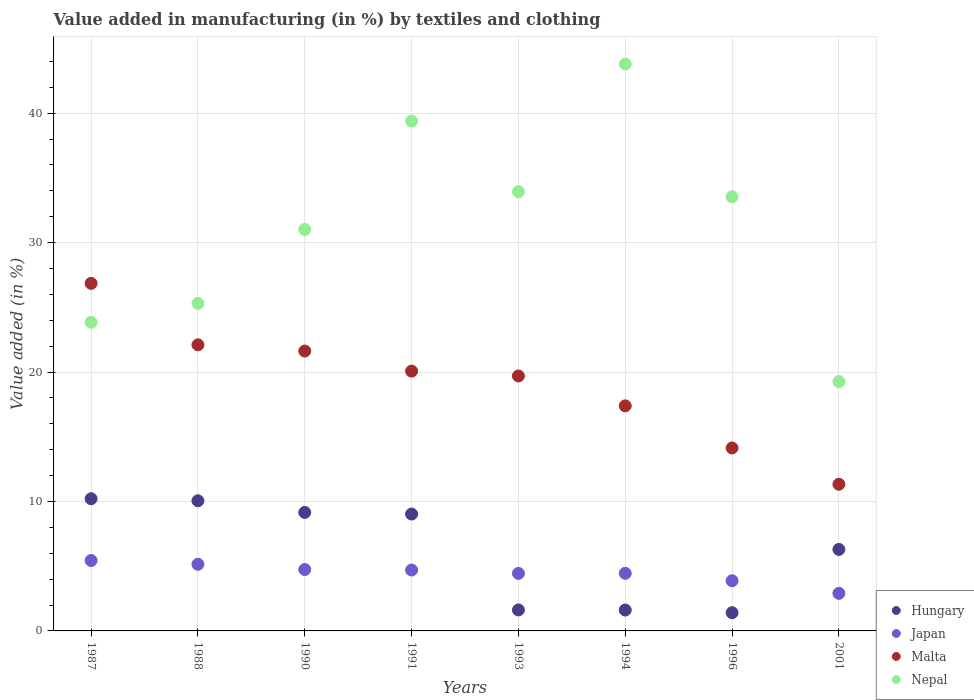Is the number of dotlines equal to the number of legend labels?
Provide a succinct answer. Yes. What is the percentage of value added in manufacturing by textiles and clothing in Malta in 2001?
Your response must be concise. 11.33. Across all years, what is the maximum percentage of value added in manufacturing by textiles and clothing in Hungary?
Keep it short and to the point. 10.21. Across all years, what is the minimum percentage of value added in manufacturing by textiles and clothing in Hungary?
Your answer should be very brief. 1.41. In which year was the percentage of value added in manufacturing by textiles and clothing in Nepal minimum?
Your response must be concise. 2001. What is the total percentage of value added in manufacturing by textiles and clothing in Japan in the graph?
Provide a succinct answer. 35.71. What is the difference between the percentage of value added in manufacturing by textiles and clothing in Malta in 1988 and that in 1996?
Ensure brevity in your answer.  7.97. What is the difference between the percentage of value added in manufacturing by textiles and clothing in Nepal in 1993 and the percentage of value added in manufacturing by textiles and clothing in Hungary in 1991?
Your answer should be very brief. 24.9. What is the average percentage of value added in manufacturing by textiles and clothing in Hungary per year?
Your answer should be very brief. 6.17. In the year 1990, what is the difference between the percentage of value added in manufacturing by textiles and clothing in Nepal and percentage of value added in manufacturing by textiles and clothing in Japan?
Your answer should be compact. 26.27. In how many years, is the percentage of value added in manufacturing by textiles and clothing in Hungary greater than 38 %?
Offer a terse response. 0. What is the ratio of the percentage of value added in manufacturing by textiles and clothing in Nepal in 1987 to that in 1991?
Provide a short and direct response. 0.61. Is the difference between the percentage of value added in manufacturing by textiles and clothing in Nepal in 1991 and 1993 greater than the difference between the percentage of value added in manufacturing by textiles and clothing in Japan in 1991 and 1993?
Provide a succinct answer. Yes. What is the difference between the highest and the second highest percentage of value added in manufacturing by textiles and clothing in Hungary?
Keep it short and to the point. 0.16. What is the difference between the highest and the lowest percentage of value added in manufacturing by textiles and clothing in Japan?
Offer a very short reply. 2.54. Is it the case that in every year, the sum of the percentage of value added in manufacturing by textiles and clothing in Nepal and percentage of value added in manufacturing by textiles and clothing in Malta  is greater than the sum of percentage of value added in manufacturing by textiles and clothing in Hungary and percentage of value added in manufacturing by textiles and clothing in Japan?
Give a very brief answer. Yes. How many years are there in the graph?
Offer a terse response. 8. What is the difference between two consecutive major ticks on the Y-axis?
Offer a terse response. 10. Are the values on the major ticks of Y-axis written in scientific E-notation?
Make the answer very short. No. Where does the legend appear in the graph?
Provide a succinct answer. Bottom right. How are the legend labels stacked?
Your answer should be very brief. Vertical. What is the title of the graph?
Give a very brief answer. Value added in manufacturing (in %) by textiles and clothing. Does "Trinidad and Tobago" appear as one of the legend labels in the graph?
Provide a succinct answer. No. What is the label or title of the X-axis?
Provide a short and direct response. Years. What is the label or title of the Y-axis?
Make the answer very short. Value added (in %). What is the Value added (in %) of Hungary in 1987?
Your answer should be very brief. 10.21. What is the Value added (in %) of Japan in 1987?
Your answer should be compact. 5.44. What is the Value added (in %) of Malta in 1987?
Ensure brevity in your answer.  26.85. What is the Value added (in %) in Nepal in 1987?
Provide a short and direct response. 23.84. What is the Value added (in %) of Hungary in 1988?
Keep it short and to the point. 10.05. What is the Value added (in %) of Japan in 1988?
Offer a terse response. 5.15. What is the Value added (in %) of Malta in 1988?
Provide a short and direct response. 22.1. What is the Value added (in %) of Nepal in 1988?
Keep it short and to the point. 25.3. What is the Value added (in %) in Hungary in 1990?
Your response must be concise. 9.15. What is the Value added (in %) in Japan in 1990?
Ensure brevity in your answer.  4.74. What is the Value added (in %) in Malta in 1990?
Your answer should be very brief. 21.62. What is the Value added (in %) in Nepal in 1990?
Give a very brief answer. 31.02. What is the Value added (in %) of Hungary in 1991?
Your answer should be compact. 9.03. What is the Value added (in %) in Japan in 1991?
Ensure brevity in your answer.  4.7. What is the Value added (in %) of Malta in 1991?
Offer a very short reply. 20.07. What is the Value added (in %) of Nepal in 1991?
Your answer should be compact. 39.39. What is the Value added (in %) of Hungary in 1993?
Your response must be concise. 1.62. What is the Value added (in %) of Japan in 1993?
Give a very brief answer. 4.45. What is the Value added (in %) of Malta in 1993?
Your answer should be very brief. 19.69. What is the Value added (in %) in Nepal in 1993?
Provide a succinct answer. 33.93. What is the Value added (in %) in Hungary in 1994?
Keep it short and to the point. 1.61. What is the Value added (in %) of Japan in 1994?
Keep it short and to the point. 4.45. What is the Value added (in %) in Malta in 1994?
Give a very brief answer. 17.39. What is the Value added (in %) of Nepal in 1994?
Keep it short and to the point. 43.79. What is the Value added (in %) in Hungary in 1996?
Give a very brief answer. 1.41. What is the Value added (in %) in Japan in 1996?
Keep it short and to the point. 3.87. What is the Value added (in %) in Malta in 1996?
Keep it short and to the point. 14.13. What is the Value added (in %) in Nepal in 1996?
Provide a succinct answer. 33.54. What is the Value added (in %) in Hungary in 2001?
Give a very brief answer. 6.3. What is the Value added (in %) in Japan in 2001?
Offer a very short reply. 2.9. What is the Value added (in %) of Malta in 2001?
Offer a very short reply. 11.33. What is the Value added (in %) in Nepal in 2001?
Offer a terse response. 19.26. Across all years, what is the maximum Value added (in %) in Hungary?
Offer a terse response. 10.21. Across all years, what is the maximum Value added (in %) of Japan?
Your response must be concise. 5.44. Across all years, what is the maximum Value added (in %) of Malta?
Your response must be concise. 26.85. Across all years, what is the maximum Value added (in %) in Nepal?
Your answer should be compact. 43.79. Across all years, what is the minimum Value added (in %) in Hungary?
Keep it short and to the point. 1.41. Across all years, what is the minimum Value added (in %) of Japan?
Provide a succinct answer. 2.9. Across all years, what is the minimum Value added (in %) of Malta?
Give a very brief answer. 11.33. Across all years, what is the minimum Value added (in %) of Nepal?
Give a very brief answer. 19.26. What is the total Value added (in %) of Hungary in the graph?
Your answer should be compact. 49.38. What is the total Value added (in %) in Japan in the graph?
Offer a very short reply. 35.71. What is the total Value added (in %) in Malta in the graph?
Keep it short and to the point. 153.18. What is the total Value added (in %) of Nepal in the graph?
Ensure brevity in your answer.  250.07. What is the difference between the Value added (in %) of Hungary in 1987 and that in 1988?
Provide a succinct answer. 0.16. What is the difference between the Value added (in %) in Japan in 1987 and that in 1988?
Provide a succinct answer. 0.29. What is the difference between the Value added (in %) in Malta in 1987 and that in 1988?
Make the answer very short. 4.75. What is the difference between the Value added (in %) of Nepal in 1987 and that in 1988?
Give a very brief answer. -1.45. What is the difference between the Value added (in %) of Hungary in 1987 and that in 1990?
Your response must be concise. 1.06. What is the difference between the Value added (in %) of Japan in 1987 and that in 1990?
Make the answer very short. 0.7. What is the difference between the Value added (in %) in Malta in 1987 and that in 1990?
Provide a short and direct response. 5.23. What is the difference between the Value added (in %) of Nepal in 1987 and that in 1990?
Keep it short and to the point. -7.17. What is the difference between the Value added (in %) of Hungary in 1987 and that in 1991?
Your response must be concise. 1.18. What is the difference between the Value added (in %) in Japan in 1987 and that in 1991?
Give a very brief answer. 0.74. What is the difference between the Value added (in %) in Malta in 1987 and that in 1991?
Provide a short and direct response. 6.78. What is the difference between the Value added (in %) of Nepal in 1987 and that in 1991?
Offer a terse response. -15.54. What is the difference between the Value added (in %) in Hungary in 1987 and that in 1993?
Provide a succinct answer. 8.59. What is the difference between the Value added (in %) of Japan in 1987 and that in 1993?
Your answer should be compact. 1. What is the difference between the Value added (in %) in Malta in 1987 and that in 1993?
Offer a very short reply. 7.15. What is the difference between the Value added (in %) in Nepal in 1987 and that in 1993?
Ensure brevity in your answer.  -10.09. What is the difference between the Value added (in %) in Hungary in 1987 and that in 1994?
Give a very brief answer. 8.6. What is the difference between the Value added (in %) of Malta in 1987 and that in 1994?
Ensure brevity in your answer.  9.46. What is the difference between the Value added (in %) in Nepal in 1987 and that in 1994?
Your answer should be very brief. -19.95. What is the difference between the Value added (in %) of Hungary in 1987 and that in 1996?
Your answer should be very brief. 8.8. What is the difference between the Value added (in %) in Japan in 1987 and that in 1996?
Your response must be concise. 1.57. What is the difference between the Value added (in %) of Malta in 1987 and that in 1996?
Make the answer very short. 12.71. What is the difference between the Value added (in %) of Nepal in 1987 and that in 1996?
Provide a succinct answer. -9.7. What is the difference between the Value added (in %) in Hungary in 1987 and that in 2001?
Your answer should be very brief. 3.92. What is the difference between the Value added (in %) of Japan in 1987 and that in 2001?
Provide a succinct answer. 2.54. What is the difference between the Value added (in %) of Malta in 1987 and that in 2001?
Give a very brief answer. 15.52. What is the difference between the Value added (in %) of Nepal in 1987 and that in 2001?
Give a very brief answer. 4.58. What is the difference between the Value added (in %) of Hungary in 1988 and that in 1990?
Your response must be concise. 0.9. What is the difference between the Value added (in %) of Japan in 1988 and that in 1990?
Offer a terse response. 0.4. What is the difference between the Value added (in %) in Malta in 1988 and that in 1990?
Offer a terse response. 0.48. What is the difference between the Value added (in %) of Nepal in 1988 and that in 1990?
Offer a very short reply. -5.72. What is the difference between the Value added (in %) in Hungary in 1988 and that in 1991?
Make the answer very short. 1.03. What is the difference between the Value added (in %) of Japan in 1988 and that in 1991?
Offer a very short reply. 0.44. What is the difference between the Value added (in %) of Malta in 1988 and that in 1991?
Provide a succinct answer. 2.03. What is the difference between the Value added (in %) of Nepal in 1988 and that in 1991?
Your answer should be very brief. -14.09. What is the difference between the Value added (in %) of Hungary in 1988 and that in 1993?
Make the answer very short. 8.43. What is the difference between the Value added (in %) in Japan in 1988 and that in 1993?
Give a very brief answer. 0.7. What is the difference between the Value added (in %) in Malta in 1988 and that in 1993?
Your answer should be compact. 2.41. What is the difference between the Value added (in %) in Nepal in 1988 and that in 1993?
Provide a succinct answer. -8.63. What is the difference between the Value added (in %) of Hungary in 1988 and that in 1994?
Provide a succinct answer. 8.44. What is the difference between the Value added (in %) of Japan in 1988 and that in 1994?
Offer a very short reply. 0.7. What is the difference between the Value added (in %) of Malta in 1988 and that in 1994?
Your answer should be compact. 4.71. What is the difference between the Value added (in %) of Nepal in 1988 and that in 1994?
Offer a very short reply. -18.5. What is the difference between the Value added (in %) of Hungary in 1988 and that in 1996?
Keep it short and to the point. 8.65. What is the difference between the Value added (in %) in Japan in 1988 and that in 1996?
Your answer should be very brief. 1.27. What is the difference between the Value added (in %) of Malta in 1988 and that in 1996?
Your answer should be very brief. 7.97. What is the difference between the Value added (in %) of Nepal in 1988 and that in 1996?
Provide a succinct answer. -8.24. What is the difference between the Value added (in %) of Hungary in 1988 and that in 2001?
Your answer should be compact. 3.76. What is the difference between the Value added (in %) of Japan in 1988 and that in 2001?
Provide a succinct answer. 2.25. What is the difference between the Value added (in %) in Malta in 1988 and that in 2001?
Provide a succinct answer. 10.77. What is the difference between the Value added (in %) of Nepal in 1988 and that in 2001?
Offer a very short reply. 6.03. What is the difference between the Value added (in %) of Hungary in 1990 and that in 1991?
Offer a very short reply. 0.13. What is the difference between the Value added (in %) of Japan in 1990 and that in 1991?
Your answer should be compact. 0.04. What is the difference between the Value added (in %) of Malta in 1990 and that in 1991?
Provide a succinct answer. 1.55. What is the difference between the Value added (in %) in Nepal in 1990 and that in 1991?
Provide a short and direct response. -8.37. What is the difference between the Value added (in %) in Hungary in 1990 and that in 1993?
Your response must be concise. 7.53. What is the difference between the Value added (in %) in Japan in 1990 and that in 1993?
Your answer should be compact. 0.3. What is the difference between the Value added (in %) of Malta in 1990 and that in 1993?
Ensure brevity in your answer.  1.93. What is the difference between the Value added (in %) in Nepal in 1990 and that in 1993?
Offer a terse response. -2.91. What is the difference between the Value added (in %) in Hungary in 1990 and that in 1994?
Offer a very short reply. 7.54. What is the difference between the Value added (in %) in Japan in 1990 and that in 1994?
Ensure brevity in your answer.  0.29. What is the difference between the Value added (in %) of Malta in 1990 and that in 1994?
Make the answer very short. 4.23. What is the difference between the Value added (in %) of Nepal in 1990 and that in 1994?
Your answer should be very brief. -12.78. What is the difference between the Value added (in %) in Hungary in 1990 and that in 1996?
Make the answer very short. 7.75. What is the difference between the Value added (in %) in Japan in 1990 and that in 1996?
Make the answer very short. 0.87. What is the difference between the Value added (in %) in Malta in 1990 and that in 1996?
Make the answer very short. 7.49. What is the difference between the Value added (in %) in Nepal in 1990 and that in 1996?
Make the answer very short. -2.52. What is the difference between the Value added (in %) in Hungary in 1990 and that in 2001?
Give a very brief answer. 2.86. What is the difference between the Value added (in %) of Japan in 1990 and that in 2001?
Your answer should be compact. 1.84. What is the difference between the Value added (in %) of Malta in 1990 and that in 2001?
Offer a terse response. 10.29. What is the difference between the Value added (in %) of Nepal in 1990 and that in 2001?
Make the answer very short. 11.75. What is the difference between the Value added (in %) of Hungary in 1991 and that in 1993?
Keep it short and to the point. 7.41. What is the difference between the Value added (in %) in Japan in 1991 and that in 1993?
Your answer should be compact. 0.26. What is the difference between the Value added (in %) of Malta in 1991 and that in 1993?
Your answer should be compact. 0.38. What is the difference between the Value added (in %) in Nepal in 1991 and that in 1993?
Ensure brevity in your answer.  5.46. What is the difference between the Value added (in %) of Hungary in 1991 and that in 1994?
Provide a short and direct response. 7.42. What is the difference between the Value added (in %) in Japan in 1991 and that in 1994?
Provide a succinct answer. 0.25. What is the difference between the Value added (in %) of Malta in 1991 and that in 1994?
Ensure brevity in your answer.  2.68. What is the difference between the Value added (in %) in Nepal in 1991 and that in 1994?
Offer a very short reply. -4.41. What is the difference between the Value added (in %) of Hungary in 1991 and that in 1996?
Provide a succinct answer. 7.62. What is the difference between the Value added (in %) of Japan in 1991 and that in 1996?
Offer a very short reply. 0.83. What is the difference between the Value added (in %) of Malta in 1991 and that in 1996?
Provide a short and direct response. 5.94. What is the difference between the Value added (in %) in Nepal in 1991 and that in 1996?
Ensure brevity in your answer.  5.85. What is the difference between the Value added (in %) of Hungary in 1991 and that in 2001?
Offer a very short reply. 2.73. What is the difference between the Value added (in %) of Japan in 1991 and that in 2001?
Offer a terse response. 1.8. What is the difference between the Value added (in %) of Malta in 1991 and that in 2001?
Keep it short and to the point. 8.74. What is the difference between the Value added (in %) in Nepal in 1991 and that in 2001?
Make the answer very short. 20.12. What is the difference between the Value added (in %) of Hungary in 1993 and that in 1994?
Your response must be concise. 0.01. What is the difference between the Value added (in %) of Japan in 1993 and that in 1994?
Offer a terse response. -0.01. What is the difference between the Value added (in %) in Malta in 1993 and that in 1994?
Offer a very short reply. 2.31. What is the difference between the Value added (in %) in Nepal in 1993 and that in 1994?
Offer a terse response. -9.86. What is the difference between the Value added (in %) of Hungary in 1993 and that in 1996?
Your answer should be compact. 0.21. What is the difference between the Value added (in %) in Japan in 1993 and that in 1996?
Offer a very short reply. 0.57. What is the difference between the Value added (in %) in Malta in 1993 and that in 1996?
Keep it short and to the point. 5.56. What is the difference between the Value added (in %) in Nepal in 1993 and that in 1996?
Keep it short and to the point. 0.39. What is the difference between the Value added (in %) of Hungary in 1993 and that in 2001?
Your answer should be very brief. -4.67. What is the difference between the Value added (in %) in Japan in 1993 and that in 2001?
Give a very brief answer. 1.54. What is the difference between the Value added (in %) in Malta in 1993 and that in 2001?
Offer a terse response. 8.36. What is the difference between the Value added (in %) of Nepal in 1993 and that in 2001?
Your response must be concise. 14.67. What is the difference between the Value added (in %) of Hungary in 1994 and that in 1996?
Offer a terse response. 0.2. What is the difference between the Value added (in %) of Japan in 1994 and that in 1996?
Provide a short and direct response. 0.58. What is the difference between the Value added (in %) in Malta in 1994 and that in 1996?
Offer a very short reply. 3.25. What is the difference between the Value added (in %) of Nepal in 1994 and that in 1996?
Your answer should be compact. 10.25. What is the difference between the Value added (in %) of Hungary in 1994 and that in 2001?
Offer a terse response. -4.68. What is the difference between the Value added (in %) of Japan in 1994 and that in 2001?
Keep it short and to the point. 1.55. What is the difference between the Value added (in %) of Malta in 1994 and that in 2001?
Your answer should be compact. 6.06. What is the difference between the Value added (in %) in Nepal in 1994 and that in 2001?
Offer a very short reply. 24.53. What is the difference between the Value added (in %) of Hungary in 1996 and that in 2001?
Keep it short and to the point. -4.89. What is the difference between the Value added (in %) in Japan in 1996 and that in 2001?
Offer a terse response. 0.97. What is the difference between the Value added (in %) in Malta in 1996 and that in 2001?
Keep it short and to the point. 2.8. What is the difference between the Value added (in %) of Nepal in 1996 and that in 2001?
Your answer should be compact. 14.28. What is the difference between the Value added (in %) in Hungary in 1987 and the Value added (in %) in Japan in 1988?
Provide a short and direct response. 5.07. What is the difference between the Value added (in %) in Hungary in 1987 and the Value added (in %) in Malta in 1988?
Keep it short and to the point. -11.89. What is the difference between the Value added (in %) of Hungary in 1987 and the Value added (in %) of Nepal in 1988?
Ensure brevity in your answer.  -15.09. What is the difference between the Value added (in %) of Japan in 1987 and the Value added (in %) of Malta in 1988?
Provide a short and direct response. -16.66. What is the difference between the Value added (in %) of Japan in 1987 and the Value added (in %) of Nepal in 1988?
Keep it short and to the point. -19.86. What is the difference between the Value added (in %) of Malta in 1987 and the Value added (in %) of Nepal in 1988?
Offer a very short reply. 1.55. What is the difference between the Value added (in %) in Hungary in 1987 and the Value added (in %) in Japan in 1990?
Your answer should be compact. 5.47. What is the difference between the Value added (in %) in Hungary in 1987 and the Value added (in %) in Malta in 1990?
Ensure brevity in your answer.  -11.41. What is the difference between the Value added (in %) in Hungary in 1987 and the Value added (in %) in Nepal in 1990?
Make the answer very short. -20.8. What is the difference between the Value added (in %) in Japan in 1987 and the Value added (in %) in Malta in 1990?
Your answer should be very brief. -16.18. What is the difference between the Value added (in %) in Japan in 1987 and the Value added (in %) in Nepal in 1990?
Provide a short and direct response. -25.58. What is the difference between the Value added (in %) of Malta in 1987 and the Value added (in %) of Nepal in 1990?
Your answer should be very brief. -4.17. What is the difference between the Value added (in %) of Hungary in 1987 and the Value added (in %) of Japan in 1991?
Your answer should be compact. 5.51. What is the difference between the Value added (in %) of Hungary in 1987 and the Value added (in %) of Malta in 1991?
Keep it short and to the point. -9.86. What is the difference between the Value added (in %) of Hungary in 1987 and the Value added (in %) of Nepal in 1991?
Ensure brevity in your answer.  -29.17. What is the difference between the Value added (in %) in Japan in 1987 and the Value added (in %) in Malta in 1991?
Your response must be concise. -14.63. What is the difference between the Value added (in %) in Japan in 1987 and the Value added (in %) in Nepal in 1991?
Keep it short and to the point. -33.95. What is the difference between the Value added (in %) of Malta in 1987 and the Value added (in %) of Nepal in 1991?
Your response must be concise. -12.54. What is the difference between the Value added (in %) in Hungary in 1987 and the Value added (in %) in Japan in 1993?
Offer a terse response. 5.77. What is the difference between the Value added (in %) in Hungary in 1987 and the Value added (in %) in Malta in 1993?
Make the answer very short. -9.48. What is the difference between the Value added (in %) of Hungary in 1987 and the Value added (in %) of Nepal in 1993?
Your response must be concise. -23.72. What is the difference between the Value added (in %) of Japan in 1987 and the Value added (in %) of Malta in 1993?
Keep it short and to the point. -14.25. What is the difference between the Value added (in %) of Japan in 1987 and the Value added (in %) of Nepal in 1993?
Offer a terse response. -28.49. What is the difference between the Value added (in %) of Malta in 1987 and the Value added (in %) of Nepal in 1993?
Keep it short and to the point. -7.08. What is the difference between the Value added (in %) of Hungary in 1987 and the Value added (in %) of Japan in 1994?
Provide a short and direct response. 5.76. What is the difference between the Value added (in %) in Hungary in 1987 and the Value added (in %) in Malta in 1994?
Offer a terse response. -7.17. What is the difference between the Value added (in %) in Hungary in 1987 and the Value added (in %) in Nepal in 1994?
Provide a short and direct response. -33.58. What is the difference between the Value added (in %) in Japan in 1987 and the Value added (in %) in Malta in 1994?
Keep it short and to the point. -11.95. What is the difference between the Value added (in %) in Japan in 1987 and the Value added (in %) in Nepal in 1994?
Your response must be concise. -38.35. What is the difference between the Value added (in %) in Malta in 1987 and the Value added (in %) in Nepal in 1994?
Offer a very short reply. -16.95. What is the difference between the Value added (in %) in Hungary in 1987 and the Value added (in %) in Japan in 1996?
Your response must be concise. 6.34. What is the difference between the Value added (in %) of Hungary in 1987 and the Value added (in %) of Malta in 1996?
Offer a very short reply. -3.92. What is the difference between the Value added (in %) of Hungary in 1987 and the Value added (in %) of Nepal in 1996?
Provide a short and direct response. -23.33. What is the difference between the Value added (in %) of Japan in 1987 and the Value added (in %) of Malta in 1996?
Offer a terse response. -8.69. What is the difference between the Value added (in %) in Japan in 1987 and the Value added (in %) in Nepal in 1996?
Provide a short and direct response. -28.1. What is the difference between the Value added (in %) of Malta in 1987 and the Value added (in %) of Nepal in 1996?
Your answer should be very brief. -6.69. What is the difference between the Value added (in %) in Hungary in 1987 and the Value added (in %) in Japan in 2001?
Your answer should be compact. 7.31. What is the difference between the Value added (in %) in Hungary in 1987 and the Value added (in %) in Malta in 2001?
Give a very brief answer. -1.12. What is the difference between the Value added (in %) in Hungary in 1987 and the Value added (in %) in Nepal in 2001?
Ensure brevity in your answer.  -9.05. What is the difference between the Value added (in %) in Japan in 1987 and the Value added (in %) in Malta in 2001?
Offer a terse response. -5.89. What is the difference between the Value added (in %) in Japan in 1987 and the Value added (in %) in Nepal in 2001?
Keep it short and to the point. -13.82. What is the difference between the Value added (in %) of Malta in 1987 and the Value added (in %) of Nepal in 2001?
Your response must be concise. 7.58. What is the difference between the Value added (in %) in Hungary in 1988 and the Value added (in %) in Japan in 1990?
Provide a succinct answer. 5.31. What is the difference between the Value added (in %) of Hungary in 1988 and the Value added (in %) of Malta in 1990?
Your answer should be very brief. -11.56. What is the difference between the Value added (in %) in Hungary in 1988 and the Value added (in %) in Nepal in 1990?
Provide a short and direct response. -20.96. What is the difference between the Value added (in %) in Japan in 1988 and the Value added (in %) in Malta in 1990?
Offer a terse response. -16.47. What is the difference between the Value added (in %) in Japan in 1988 and the Value added (in %) in Nepal in 1990?
Your response must be concise. -25.87. What is the difference between the Value added (in %) in Malta in 1988 and the Value added (in %) in Nepal in 1990?
Offer a very short reply. -8.92. What is the difference between the Value added (in %) in Hungary in 1988 and the Value added (in %) in Japan in 1991?
Make the answer very short. 5.35. What is the difference between the Value added (in %) in Hungary in 1988 and the Value added (in %) in Malta in 1991?
Offer a terse response. -10.02. What is the difference between the Value added (in %) in Hungary in 1988 and the Value added (in %) in Nepal in 1991?
Make the answer very short. -29.33. What is the difference between the Value added (in %) of Japan in 1988 and the Value added (in %) of Malta in 1991?
Keep it short and to the point. -14.92. What is the difference between the Value added (in %) of Japan in 1988 and the Value added (in %) of Nepal in 1991?
Ensure brevity in your answer.  -34.24. What is the difference between the Value added (in %) of Malta in 1988 and the Value added (in %) of Nepal in 1991?
Your answer should be very brief. -17.29. What is the difference between the Value added (in %) of Hungary in 1988 and the Value added (in %) of Japan in 1993?
Your answer should be compact. 5.61. What is the difference between the Value added (in %) of Hungary in 1988 and the Value added (in %) of Malta in 1993?
Provide a succinct answer. -9.64. What is the difference between the Value added (in %) of Hungary in 1988 and the Value added (in %) of Nepal in 1993?
Make the answer very short. -23.87. What is the difference between the Value added (in %) of Japan in 1988 and the Value added (in %) of Malta in 1993?
Your answer should be compact. -14.55. What is the difference between the Value added (in %) of Japan in 1988 and the Value added (in %) of Nepal in 1993?
Your answer should be very brief. -28.78. What is the difference between the Value added (in %) in Malta in 1988 and the Value added (in %) in Nepal in 1993?
Your answer should be compact. -11.83. What is the difference between the Value added (in %) in Hungary in 1988 and the Value added (in %) in Japan in 1994?
Your answer should be compact. 5.6. What is the difference between the Value added (in %) in Hungary in 1988 and the Value added (in %) in Malta in 1994?
Provide a succinct answer. -7.33. What is the difference between the Value added (in %) in Hungary in 1988 and the Value added (in %) in Nepal in 1994?
Give a very brief answer. -33.74. What is the difference between the Value added (in %) of Japan in 1988 and the Value added (in %) of Malta in 1994?
Keep it short and to the point. -12.24. What is the difference between the Value added (in %) in Japan in 1988 and the Value added (in %) in Nepal in 1994?
Provide a short and direct response. -38.65. What is the difference between the Value added (in %) in Malta in 1988 and the Value added (in %) in Nepal in 1994?
Offer a very short reply. -21.69. What is the difference between the Value added (in %) in Hungary in 1988 and the Value added (in %) in Japan in 1996?
Your response must be concise. 6.18. What is the difference between the Value added (in %) in Hungary in 1988 and the Value added (in %) in Malta in 1996?
Provide a short and direct response. -4.08. What is the difference between the Value added (in %) of Hungary in 1988 and the Value added (in %) of Nepal in 1996?
Provide a short and direct response. -23.48. What is the difference between the Value added (in %) in Japan in 1988 and the Value added (in %) in Malta in 1996?
Your answer should be compact. -8.99. What is the difference between the Value added (in %) in Japan in 1988 and the Value added (in %) in Nepal in 1996?
Provide a succinct answer. -28.39. What is the difference between the Value added (in %) in Malta in 1988 and the Value added (in %) in Nepal in 1996?
Keep it short and to the point. -11.44. What is the difference between the Value added (in %) in Hungary in 1988 and the Value added (in %) in Japan in 2001?
Your response must be concise. 7.15. What is the difference between the Value added (in %) of Hungary in 1988 and the Value added (in %) of Malta in 2001?
Make the answer very short. -1.28. What is the difference between the Value added (in %) of Hungary in 1988 and the Value added (in %) of Nepal in 2001?
Your answer should be compact. -9.21. What is the difference between the Value added (in %) of Japan in 1988 and the Value added (in %) of Malta in 2001?
Offer a very short reply. -6.18. What is the difference between the Value added (in %) of Japan in 1988 and the Value added (in %) of Nepal in 2001?
Make the answer very short. -14.12. What is the difference between the Value added (in %) of Malta in 1988 and the Value added (in %) of Nepal in 2001?
Offer a very short reply. 2.84. What is the difference between the Value added (in %) of Hungary in 1990 and the Value added (in %) of Japan in 1991?
Keep it short and to the point. 4.45. What is the difference between the Value added (in %) of Hungary in 1990 and the Value added (in %) of Malta in 1991?
Ensure brevity in your answer.  -10.92. What is the difference between the Value added (in %) of Hungary in 1990 and the Value added (in %) of Nepal in 1991?
Your response must be concise. -30.23. What is the difference between the Value added (in %) of Japan in 1990 and the Value added (in %) of Malta in 1991?
Offer a very short reply. -15.33. What is the difference between the Value added (in %) of Japan in 1990 and the Value added (in %) of Nepal in 1991?
Your response must be concise. -34.64. What is the difference between the Value added (in %) in Malta in 1990 and the Value added (in %) in Nepal in 1991?
Provide a short and direct response. -17.77. What is the difference between the Value added (in %) of Hungary in 1990 and the Value added (in %) of Japan in 1993?
Give a very brief answer. 4.71. What is the difference between the Value added (in %) of Hungary in 1990 and the Value added (in %) of Malta in 1993?
Ensure brevity in your answer.  -10.54. What is the difference between the Value added (in %) of Hungary in 1990 and the Value added (in %) of Nepal in 1993?
Your response must be concise. -24.78. What is the difference between the Value added (in %) of Japan in 1990 and the Value added (in %) of Malta in 1993?
Offer a terse response. -14.95. What is the difference between the Value added (in %) of Japan in 1990 and the Value added (in %) of Nepal in 1993?
Make the answer very short. -29.18. What is the difference between the Value added (in %) of Malta in 1990 and the Value added (in %) of Nepal in 1993?
Provide a short and direct response. -12.31. What is the difference between the Value added (in %) of Hungary in 1990 and the Value added (in %) of Japan in 1994?
Give a very brief answer. 4.7. What is the difference between the Value added (in %) of Hungary in 1990 and the Value added (in %) of Malta in 1994?
Your answer should be very brief. -8.23. What is the difference between the Value added (in %) in Hungary in 1990 and the Value added (in %) in Nepal in 1994?
Keep it short and to the point. -34.64. What is the difference between the Value added (in %) of Japan in 1990 and the Value added (in %) of Malta in 1994?
Provide a short and direct response. -12.64. What is the difference between the Value added (in %) in Japan in 1990 and the Value added (in %) in Nepal in 1994?
Offer a very short reply. -39.05. What is the difference between the Value added (in %) of Malta in 1990 and the Value added (in %) of Nepal in 1994?
Make the answer very short. -22.17. What is the difference between the Value added (in %) in Hungary in 1990 and the Value added (in %) in Japan in 1996?
Your answer should be very brief. 5.28. What is the difference between the Value added (in %) of Hungary in 1990 and the Value added (in %) of Malta in 1996?
Keep it short and to the point. -4.98. What is the difference between the Value added (in %) of Hungary in 1990 and the Value added (in %) of Nepal in 1996?
Your response must be concise. -24.39. What is the difference between the Value added (in %) of Japan in 1990 and the Value added (in %) of Malta in 1996?
Ensure brevity in your answer.  -9.39. What is the difference between the Value added (in %) in Japan in 1990 and the Value added (in %) in Nepal in 1996?
Give a very brief answer. -28.8. What is the difference between the Value added (in %) in Malta in 1990 and the Value added (in %) in Nepal in 1996?
Your answer should be compact. -11.92. What is the difference between the Value added (in %) in Hungary in 1990 and the Value added (in %) in Japan in 2001?
Give a very brief answer. 6.25. What is the difference between the Value added (in %) of Hungary in 1990 and the Value added (in %) of Malta in 2001?
Your answer should be compact. -2.18. What is the difference between the Value added (in %) in Hungary in 1990 and the Value added (in %) in Nepal in 2001?
Make the answer very short. -10.11. What is the difference between the Value added (in %) in Japan in 1990 and the Value added (in %) in Malta in 2001?
Ensure brevity in your answer.  -6.59. What is the difference between the Value added (in %) in Japan in 1990 and the Value added (in %) in Nepal in 2001?
Your response must be concise. -14.52. What is the difference between the Value added (in %) in Malta in 1990 and the Value added (in %) in Nepal in 2001?
Your answer should be compact. 2.36. What is the difference between the Value added (in %) of Hungary in 1991 and the Value added (in %) of Japan in 1993?
Give a very brief answer. 4.58. What is the difference between the Value added (in %) in Hungary in 1991 and the Value added (in %) in Malta in 1993?
Your answer should be very brief. -10.67. What is the difference between the Value added (in %) of Hungary in 1991 and the Value added (in %) of Nepal in 1993?
Your answer should be very brief. -24.9. What is the difference between the Value added (in %) in Japan in 1991 and the Value added (in %) in Malta in 1993?
Your response must be concise. -14.99. What is the difference between the Value added (in %) in Japan in 1991 and the Value added (in %) in Nepal in 1993?
Keep it short and to the point. -29.23. What is the difference between the Value added (in %) of Malta in 1991 and the Value added (in %) of Nepal in 1993?
Offer a terse response. -13.86. What is the difference between the Value added (in %) in Hungary in 1991 and the Value added (in %) in Japan in 1994?
Provide a short and direct response. 4.58. What is the difference between the Value added (in %) of Hungary in 1991 and the Value added (in %) of Malta in 1994?
Your response must be concise. -8.36. What is the difference between the Value added (in %) of Hungary in 1991 and the Value added (in %) of Nepal in 1994?
Give a very brief answer. -34.77. What is the difference between the Value added (in %) in Japan in 1991 and the Value added (in %) in Malta in 1994?
Keep it short and to the point. -12.68. What is the difference between the Value added (in %) in Japan in 1991 and the Value added (in %) in Nepal in 1994?
Provide a succinct answer. -39.09. What is the difference between the Value added (in %) of Malta in 1991 and the Value added (in %) of Nepal in 1994?
Give a very brief answer. -23.72. What is the difference between the Value added (in %) in Hungary in 1991 and the Value added (in %) in Japan in 1996?
Offer a very short reply. 5.15. What is the difference between the Value added (in %) of Hungary in 1991 and the Value added (in %) of Malta in 1996?
Your answer should be very brief. -5.1. What is the difference between the Value added (in %) in Hungary in 1991 and the Value added (in %) in Nepal in 1996?
Make the answer very short. -24.51. What is the difference between the Value added (in %) in Japan in 1991 and the Value added (in %) in Malta in 1996?
Your answer should be compact. -9.43. What is the difference between the Value added (in %) of Japan in 1991 and the Value added (in %) of Nepal in 1996?
Give a very brief answer. -28.84. What is the difference between the Value added (in %) in Malta in 1991 and the Value added (in %) in Nepal in 1996?
Offer a very short reply. -13.47. What is the difference between the Value added (in %) of Hungary in 1991 and the Value added (in %) of Japan in 2001?
Make the answer very short. 6.13. What is the difference between the Value added (in %) of Hungary in 1991 and the Value added (in %) of Malta in 2001?
Offer a terse response. -2.3. What is the difference between the Value added (in %) in Hungary in 1991 and the Value added (in %) in Nepal in 2001?
Offer a terse response. -10.24. What is the difference between the Value added (in %) in Japan in 1991 and the Value added (in %) in Malta in 2001?
Offer a very short reply. -6.63. What is the difference between the Value added (in %) of Japan in 1991 and the Value added (in %) of Nepal in 2001?
Your answer should be very brief. -14.56. What is the difference between the Value added (in %) in Malta in 1991 and the Value added (in %) in Nepal in 2001?
Your answer should be very brief. 0.81. What is the difference between the Value added (in %) in Hungary in 1993 and the Value added (in %) in Japan in 1994?
Give a very brief answer. -2.83. What is the difference between the Value added (in %) in Hungary in 1993 and the Value added (in %) in Malta in 1994?
Your answer should be very brief. -15.76. What is the difference between the Value added (in %) in Hungary in 1993 and the Value added (in %) in Nepal in 1994?
Your answer should be compact. -42.17. What is the difference between the Value added (in %) in Japan in 1993 and the Value added (in %) in Malta in 1994?
Provide a succinct answer. -12.94. What is the difference between the Value added (in %) in Japan in 1993 and the Value added (in %) in Nepal in 1994?
Provide a short and direct response. -39.35. What is the difference between the Value added (in %) of Malta in 1993 and the Value added (in %) of Nepal in 1994?
Offer a terse response. -24.1. What is the difference between the Value added (in %) in Hungary in 1993 and the Value added (in %) in Japan in 1996?
Give a very brief answer. -2.25. What is the difference between the Value added (in %) of Hungary in 1993 and the Value added (in %) of Malta in 1996?
Ensure brevity in your answer.  -12.51. What is the difference between the Value added (in %) in Hungary in 1993 and the Value added (in %) in Nepal in 1996?
Give a very brief answer. -31.92. What is the difference between the Value added (in %) of Japan in 1993 and the Value added (in %) of Malta in 1996?
Give a very brief answer. -9.69. What is the difference between the Value added (in %) of Japan in 1993 and the Value added (in %) of Nepal in 1996?
Offer a very short reply. -29.09. What is the difference between the Value added (in %) in Malta in 1993 and the Value added (in %) in Nepal in 1996?
Your answer should be very brief. -13.85. What is the difference between the Value added (in %) in Hungary in 1993 and the Value added (in %) in Japan in 2001?
Provide a short and direct response. -1.28. What is the difference between the Value added (in %) of Hungary in 1993 and the Value added (in %) of Malta in 2001?
Give a very brief answer. -9.71. What is the difference between the Value added (in %) in Hungary in 1993 and the Value added (in %) in Nepal in 2001?
Ensure brevity in your answer.  -17.64. What is the difference between the Value added (in %) in Japan in 1993 and the Value added (in %) in Malta in 2001?
Offer a terse response. -6.89. What is the difference between the Value added (in %) in Japan in 1993 and the Value added (in %) in Nepal in 2001?
Offer a very short reply. -14.82. What is the difference between the Value added (in %) in Malta in 1993 and the Value added (in %) in Nepal in 2001?
Make the answer very short. 0.43. What is the difference between the Value added (in %) in Hungary in 1994 and the Value added (in %) in Japan in 1996?
Offer a very short reply. -2.26. What is the difference between the Value added (in %) of Hungary in 1994 and the Value added (in %) of Malta in 1996?
Give a very brief answer. -12.52. What is the difference between the Value added (in %) of Hungary in 1994 and the Value added (in %) of Nepal in 1996?
Give a very brief answer. -31.93. What is the difference between the Value added (in %) of Japan in 1994 and the Value added (in %) of Malta in 1996?
Make the answer very short. -9.68. What is the difference between the Value added (in %) in Japan in 1994 and the Value added (in %) in Nepal in 1996?
Offer a very short reply. -29.09. What is the difference between the Value added (in %) of Malta in 1994 and the Value added (in %) of Nepal in 1996?
Offer a very short reply. -16.15. What is the difference between the Value added (in %) in Hungary in 1994 and the Value added (in %) in Japan in 2001?
Provide a short and direct response. -1.29. What is the difference between the Value added (in %) of Hungary in 1994 and the Value added (in %) of Malta in 2001?
Give a very brief answer. -9.72. What is the difference between the Value added (in %) in Hungary in 1994 and the Value added (in %) in Nepal in 2001?
Keep it short and to the point. -17.65. What is the difference between the Value added (in %) in Japan in 1994 and the Value added (in %) in Malta in 2001?
Make the answer very short. -6.88. What is the difference between the Value added (in %) in Japan in 1994 and the Value added (in %) in Nepal in 2001?
Keep it short and to the point. -14.81. What is the difference between the Value added (in %) of Malta in 1994 and the Value added (in %) of Nepal in 2001?
Your response must be concise. -1.88. What is the difference between the Value added (in %) of Hungary in 1996 and the Value added (in %) of Japan in 2001?
Provide a short and direct response. -1.49. What is the difference between the Value added (in %) in Hungary in 1996 and the Value added (in %) in Malta in 2001?
Your response must be concise. -9.92. What is the difference between the Value added (in %) in Hungary in 1996 and the Value added (in %) in Nepal in 2001?
Make the answer very short. -17.86. What is the difference between the Value added (in %) of Japan in 1996 and the Value added (in %) of Malta in 2001?
Provide a short and direct response. -7.46. What is the difference between the Value added (in %) in Japan in 1996 and the Value added (in %) in Nepal in 2001?
Your answer should be very brief. -15.39. What is the difference between the Value added (in %) in Malta in 1996 and the Value added (in %) in Nepal in 2001?
Provide a short and direct response. -5.13. What is the average Value added (in %) in Hungary per year?
Your answer should be very brief. 6.17. What is the average Value added (in %) of Japan per year?
Keep it short and to the point. 4.46. What is the average Value added (in %) of Malta per year?
Your answer should be compact. 19.15. What is the average Value added (in %) in Nepal per year?
Offer a terse response. 31.26. In the year 1987, what is the difference between the Value added (in %) in Hungary and Value added (in %) in Japan?
Provide a succinct answer. 4.77. In the year 1987, what is the difference between the Value added (in %) in Hungary and Value added (in %) in Malta?
Your answer should be very brief. -16.64. In the year 1987, what is the difference between the Value added (in %) of Hungary and Value added (in %) of Nepal?
Your answer should be very brief. -13.63. In the year 1987, what is the difference between the Value added (in %) in Japan and Value added (in %) in Malta?
Provide a short and direct response. -21.41. In the year 1987, what is the difference between the Value added (in %) in Japan and Value added (in %) in Nepal?
Your answer should be very brief. -18.4. In the year 1987, what is the difference between the Value added (in %) in Malta and Value added (in %) in Nepal?
Ensure brevity in your answer.  3. In the year 1988, what is the difference between the Value added (in %) of Hungary and Value added (in %) of Japan?
Your answer should be compact. 4.91. In the year 1988, what is the difference between the Value added (in %) in Hungary and Value added (in %) in Malta?
Provide a short and direct response. -12.05. In the year 1988, what is the difference between the Value added (in %) in Hungary and Value added (in %) in Nepal?
Offer a very short reply. -15.24. In the year 1988, what is the difference between the Value added (in %) of Japan and Value added (in %) of Malta?
Provide a succinct answer. -16.95. In the year 1988, what is the difference between the Value added (in %) of Japan and Value added (in %) of Nepal?
Your response must be concise. -20.15. In the year 1988, what is the difference between the Value added (in %) of Malta and Value added (in %) of Nepal?
Your answer should be compact. -3.2. In the year 1990, what is the difference between the Value added (in %) in Hungary and Value added (in %) in Japan?
Provide a short and direct response. 4.41. In the year 1990, what is the difference between the Value added (in %) in Hungary and Value added (in %) in Malta?
Provide a short and direct response. -12.47. In the year 1990, what is the difference between the Value added (in %) in Hungary and Value added (in %) in Nepal?
Provide a succinct answer. -21.86. In the year 1990, what is the difference between the Value added (in %) in Japan and Value added (in %) in Malta?
Your response must be concise. -16.88. In the year 1990, what is the difference between the Value added (in %) of Japan and Value added (in %) of Nepal?
Make the answer very short. -26.27. In the year 1990, what is the difference between the Value added (in %) of Malta and Value added (in %) of Nepal?
Ensure brevity in your answer.  -9.4. In the year 1991, what is the difference between the Value added (in %) of Hungary and Value added (in %) of Japan?
Give a very brief answer. 4.32. In the year 1991, what is the difference between the Value added (in %) in Hungary and Value added (in %) in Malta?
Your answer should be compact. -11.04. In the year 1991, what is the difference between the Value added (in %) of Hungary and Value added (in %) of Nepal?
Your answer should be very brief. -30.36. In the year 1991, what is the difference between the Value added (in %) of Japan and Value added (in %) of Malta?
Your answer should be very brief. -15.37. In the year 1991, what is the difference between the Value added (in %) in Japan and Value added (in %) in Nepal?
Your answer should be compact. -34.68. In the year 1991, what is the difference between the Value added (in %) in Malta and Value added (in %) in Nepal?
Your answer should be compact. -19.32. In the year 1993, what is the difference between the Value added (in %) in Hungary and Value added (in %) in Japan?
Provide a succinct answer. -2.82. In the year 1993, what is the difference between the Value added (in %) of Hungary and Value added (in %) of Malta?
Give a very brief answer. -18.07. In the year 1993, what is the difference between the Value added (in %) of Hungary and Value added (in %) of Nepal?
Offer a terse response. -32.31. In the year 1993, what is the difference between the Value added (in %) in Japan and Value added (in %) in Malta?
Your answer should be compact. -15.25. In the year 1993, what is the difference between the Value added (in %) in Japan and Value added (in %) in Nepal?
Offer a terse response. -29.48. In the year 1993, what is the difference between the Value added (in %) of Malta and Value added (in %) of Nepal?
Give a very brief answer. -14.23. In the year 1994, what is the difference between the Value added (in %) of Hungary and Value added (in %) of Japan?
Keep it short and to the point. -2.84. In the year 1994, what is the difference between the Value added (in %) in Hungary and Value added (in %) in Malta?
Your answer should be compact. -15.77. In the year 1994, what is the difference between the Value added (in %) in Hungary and Value added (in %) in Nepal?
Your response must be concise. -42.18. In the year 1994, what is the difference between the Value added (in %) of Japan and Value added (in %) of Malta?
Your answer should be compact. -12.93. In the year 1994, what is the difference between the Value added (in %) of Japan and Value added (in %) of Nepal?
Provide a succinct answer. -39.34. In the year 1994, what is the difference between the Value added (in %) in Malta and Value added (in %) in Nepal?
Keep it short and to the point. -26.41. In the year 1996, what is the difference between the Value added (in %) in Hungary and Value added (in %) in Japan?
Your answer should be compact. -2.47. In the year 1996, what is the difference between the Value added (in %) of Hungary and Value added (in %) of Malta?
Your answer should be very brief. -12.73. In the year 1996, what is the difference between the Value added (in %) of Hungary and Value added (in %) of Nepal?
Provide a short and direct response. -32.13. In the year 1996, what is the difference between the Value added (in %) of Japan and Value added (in %) of Malta?
Your answer should be very brief. -10.26. In the year 1996, what is the difference between the Value added (in %) in Japan and Value added (in %) in Nepal?
Make the answer very short. -29.67. In the year 1996, what is the difference between the Value added (in %) in Malta and Value added (in %) in Nepal?
Your answer should be very brief. -19.41. In the year 2001, what is the difference between the Value added (in %) in Hungary and Value added (in %) in Japan?
Offer a terse response. 3.39. In the year 2001, what is the difference between the Value added (in %) of Hungary and Value added (in %) of Malta?
Provide a succinct answer. -5.03. In the year 2001, what is the difference between the Value added (in %) of Hungary and Value added (in %) of Nepal?
Provide a short and direct response. -12.97. In the year 2001, what is the difference between the Value added (in %) of Japan and Value added (in %) of Malta?
Your response must be concise. -8.43. In the year 2001, what is the difference between the Value added (in %) in Japan and Value added (in %) in Nepal?
Offer a very short reply. -16.36. In the year 2001, what is the difference between the Value added (in %) in Malta and Value added (in %) in Nepal?
Ensure brevity in your answer.  -7.93. What is the ratio of the Value added (in %) of Hungary in 1987 to that in 1988?
Keep it short and to the point. 1.02. What is the ratio of the Value added (in %) of Japan in 1987 to that in 1988?
Your response must be concise. 1.06. What is the ratio of the Value added (in %) of Malta in 1987 to that in 1988?
Provide a succinct answer. 1.21. What is the ratio of the Value added (in %) of Nepal in 1987 to that in 1988?
Provide a short and direct response. 0.94. What is the ratio of the Value added (in %) in Hungary in 1987 to that in 1990?
Give a very brief answer. 1.12. What is the ratio of the Value added (in %) of Japan in 1987 to that in 1990?
Your answer should be very brief. 1.15. What is the ratio of the Value added (in %) of Malta in 1987 to that in 1990?
Offer a very short reply. 1.24. What is the ratio of the Value added (in %) in Nepal in 1987 to that in 1990?
Make the answer very short. 0.77. What is the ratio of the Value added (in %) of Hungary in 1987 to that in 1991?
Your answer should be compact. 1.13. What is the ratio of the Value added (in %) in Japan in 1987 to that in 1991?
Your answer should be compact. 1.16. What is the ratio of the Value added (in %) in Malta in 1987 to that in 1991?
Your response must be concise. 1.34. What is the ratio of the Value added (in %) in Nepal in 1987 to that in 1991?
Offer a very short reply. 0.61. What is the ratio of the Value added (in %) of Hungary in 1987 to that in 1993?
Your response must be concise. 6.3. What is the ratio of the Value added (in %) of Japan in 1987 to that in 1993?
Keep it short and to the point. 1.22. What is the ratio of the Value added (in %) of Malta in 1987 to that in 1993?
Offer a terse response. 1.36. What is the ratio of the Value added (in %) of Nepal in 1987 to that in 1993?
Give a very brief answer. 0.7. What is the ratio of the Value added (in %) of Hungary in 1987 to that in 1994?
Your answer should be compact. 6.34. What is the ratio of the Value added (in %) in Japan in 1987 to that in 1994?
Make the answer very short. 1.22. What is the ratio of the Value added (in %) in Malta in 1987 to that in 1994?
Offer a very short reply. 1.54. What is the ratio of the Value added (in %) of Nepal in 1987 to that in 1994?
Your response must be concise. 0.54. What is the ratio of the Value added (in %) of Hungary in 1987 to that in 1996?
Keep it short and to the point. 7.26. What is the ratio of the Value added (in %) of Japan in 1987 to that in 1996?
Make the answer very short. 1.4. What is the ratio of the Value added (in %) in Malta in 1987 to that in 1996?
Provide a short and direct response. 1.9. What is the ratio of the Value added (in %) of Nepal in 1987 to that in 1996?
Offer a very short reply. 0.71. What is the ratio of the Value added (in %) of Hungary in 1987 to that in 2001?
Offer a very short reply. 1.62. What is the ratio of the Value added (in %) of Japan in 1987 to that in 2001?
Your answer should be very brief. 1.88. What is the ratio of the Value added (in %) of Malta in 1987 to that in 2001?
Your response must be concise. 2.37. What is the ratio of the Value added (in %) of Nepal in 1987 to that in 2001?
Give a very brief answer. 1.24. What is the ratio of the Value added (in %) in Hungary in 1988 to that in 1990?
Keep it short and to the point. 1.1. What is the ratio of the Value added (in %) in Japan in 1988 to that in 1990?
Provide a short and direct response. 1.08. What is the ratio of the Value added (in %) in Malta in 1988 to that in 1990?
Your answer should be very brief. 1.02. What is the ratio of the Value added (in %) of Nepal in 1988 to that in 1990?
Your answer should be very brief. 0.82. What is the ratio of the Value added (in %) of Hungary in 1988 to that in 1991?
Your answer should be very brief. 1.11. What is the ratio of the Value added (in %) of Japan in 1988 to that in 1991?
Your response must be concise. 1.09. What is the ratio of the Value added (in %) in Malta in 1988 to that in 1991?
Your answer should be compact. 1.1. What is the ratio of the Value added (in %) in Nepal in 1988 to that in 1991?
Keep it short and to the point. 0.64. What is the ratio of the Value added (in %) in Hungary in 1988 to that in 1993?
Make the answer very short. 6.2. What is the ratio of the Value added (in %) in Japan in 1988 to that in 1993?
Make the answer very short. 1.16. What is the ratio of the Value added (in %) in Malta in 1988 to that in 1993?
Ensure brevity in your answer.  1.12. What is the ratio of the Value added (in %) in Nepal in 1988 to that in 1993?
Your answer should be very brief. 0.75. What is the ratio of the Value added (in %) of Hungary in 1988 to that in 1994?
Make the answer very short. 6.24. What is the ratio of the Value added (in %) in Japan in 1988 to that in 1994?
Your response must be concise. 1.16. What is the ratio of the Value added (in %) in Malta in 1988 to that in 1994?
Make the answer very short. 1.27. What is the ratio of the Value added (in %) in Nepal in 1988 to that in 1994?
Ensure brevity in your answer.  0.58. What is the ratio of the Value added (in %) of Hungary in 1988 to that in 1996?
Make the answer very short. 7.14. What is the ratio of the Value added (in %) of Japan in 1988 to that in 1996?
Ensure brevity in your answer.  1.33. What is the ratio of the Value added (in %) of Malta in 1988 to that in 1996?
Your answer should be compact. 1.56. What is the ratio of the Value added (in %) of Nepal in 1988 to that in 1996?
Provide a short and direct response. 0.75. What is the ratio of the Value added (in %) of Hungary in 1988 to that in 2001?
Offer a terse response. 1.6. What is the ratio of the Value added (in %) in Japan in 1988 to that in 2001?
Keep it short and to the point. 1.77. What is the ratio of the Value added (in %) of Malta in 1988 to that in 2001?
Ensure brevity in your answer.  1.95. What is the ratio of the Value added (in %) of Nepal in 1988 to that in 2001?
Your answer should be very brief. 1.31. What is the ratio of the Value added (in %) of Hungary in 1990 to that in 1991?
Your answer should be very brief. 1.01. What is the ratio of the Value added (in %) of Japan in 1990 to that in 1991?
Your answer should be compact. 1.01. What is the ratio of the Value added (in %) of Malta in 1990 to that in 1991?
Provide a short and direct response. 1.08. What is the ratio of the Value added (in %) in Nepal in 1990 to that in 1991?
Keep it short and to the point. 0.79. What is the ratio of the Value added (in %) of Hungary in 1990 to that in 1993?
Make the answer very short. 5.65. What is the ratio of the Value added (in %) in Japan in 1990 to that in 1993?
Keep it short and to the point. 1.07. What is the ratio of the Value added (in %) in Malta in 1990 to that in 1993?
Provide a succinct answer. 1.1. What is the ratio of the Value added (in %) in Nepal in 1990 to that in 1993?
Your answer should be very brief. 0.91. What is the ratio of the Value added (in %) of Hungary in 1990 to that in 1994?
Your answer should be compact. 5.68. What is the ratio of the Value added (in %) in Japan in 1990 to that in 1994?
Your answer should be very brief. 1.07. What is the ratio of the Value added (in %) of Malta in 1990 to that in 1994?
Provide a short and direct response. 1.24. What is the ratio of the Value added (in %) in Nepal in 1990 to that in 1994?
Keep it short and to the point. 0.71. What is the ratio of the Value added (in %) of Hungary in 1990 to that in 1996?
Your answer should be compact. 6.5. What is the ratio of the Value added (in %) in Japan in 1990 to that in 1996?
Your answer should be very brief. 1.22. What is the ratio of the Value added (in %) of Malta in 1990 to that in 1996?
Your response must be concise. 1.53. What is the ratio of the Value added (in %) of Nepal in 1990 to that in 1996?
Your answer should be compact. 0.92. What is the ratio of the Value added (in %) in Hungary in 1990 to that in 2001?
Make the answer very short. 1.45. What is the ratio of the Value added (in %) in Japan in 1990 to that in 2001?
Offer a very short reply. 1.64. What is the ratio of the Value added (in %) of Malta in 1990 to that in 2001?
Your answer should be compact. 1.91. What is the ratio of the Value added (in %) in Nepal in 1990 to that in 2001?
Provide a short and direct response. 1.61. What is the ratio of the Value added (in %) of Hungary in 1991 to that in 1993?
Ensure brevity in your answer.  5.57. What is the ratio of the Value added (in %) of Japan in 1991 to that in 1993?
Your answer should be compact. 1.06. What is the ratio of the Value added (in %) in Malta in 1991 to that in 1993?
Your answer should be compact. 1.02. What is the ratio of the Value added (in %) of Nepal in 1991 to that in 1993?
Your answer should be very brief. 1.16. What is the ratio of the Value added (in %) in Hungary in 1991 to that in 1994?
Ensure brevity in your answer.  5.6. What is the ratio of the Value added (in %) in Japan in 1991 to that in 1994?
Provide a succinct answer. 1.06. What is the ratio of the Value added (in %) in Malta in 1991 to that in 1994?
Provide a short and direct response. 1.15. What is the ratio of the Value added (in %) in Nepal in 1991 to that in 1994?
Your answer should be very brief. 0.9. What is the ratio of the Value added (in %) of Hungary in 1991 to that in 1996?
Keep it short and to the point. 6.42. What is the ratio of the Value added (in %) in Japan in 1991 to that in 1996?
Offer a terse response. 1.21. What is the ratio of the Value added (in %) in Malta in 1991 to that in 1996?
Make the answer very short. 1.42. What is the ratio of the Value added (in %) in Nepal in 1991 to that in 1996?
Make the answer very short. 1.17. What is the ratio of the Value added (in %) in Hungary in 1991 to that in 2001?
Provide a succinct answer. 1.43. What is the ratio of the Value added (in %) of Japan in 1991 to that in 2001?
Your answer should be very brief. 1.62. What is the ratio of the Value added (in %) in Malta in 1991 to that in 2001?
Your response must be concise. 1.77. What is the ratio of the Value added (in %) in Nepal in 1991 to that in 2001?
Your answer should be compact. 2.04. What is the ratio of the Value added (in %) in Hungary in 1993 to that in 1994?
Your answer should be compact. 1.01. What is the ratio of the Value added (in %) in Japan in 1993 to that in 1994?
Provide a succinct answer. 1. What is the ratio of the Value added (in %) in Malta in 1993 to that in 1994?
Give a very brief answer. 1.13. What is the ratio of the Value added (in %) of Nepal in 1993 to that in 1994?
Provide a short and direct response. 0.77. What is the ratio of the Value added (in %) in Hungary in 1993 to that in 1996?
Give a very brief answer. 1.15. What is the ratio of the Value added (in %) of Japan in 1993 to that in 1996?
Provide a short and direct response. 1.15. What is the ratio of the Value added (in %) in Malta in 1993 to that in 1996?
Your answer should be very brief. 1.39. What is the ratio of the Value added (in %) of Nepal in 1993 to that in 1996?
Provide a short and direct response. 1.01. What is the ratio of the Value added (in %) of Hungary in 1993 to that in 2001?
Your answer should be very brief. 0.26. What is the ratio of the Value added (in %) in Japan in 1993 to that in 2001?
Your response must be concise. 1.53. What is the ratio of the Value added (in %) in Malta in 1993 to that in 2001?
Your answer should be very brief. 1.74. What is the ratio of the Value added (in %) in Nepal in 1993 to that in 2001?
Offer a very short reply. 1.76. What is the ratio of the Value added (in %) in Hungary in 1994 to that in 1996?
Your answer should be very brief. 1.15. What is the ratio of the Value added (in %) of Japan in 1994 to that in 1996?
Offer a very short reply. 1.15. What is the ratio of the Value added (in %) in Malta in 1994 to that in 1996?
Keep it short and to the point. 1.23. What is the ratio of the Value added (in %) in Nepal in 1994 to that in 1996?
Provide a succinct answer. 1.31. What is the ratio of the Value added (in %) of Hungary in 1994 to that in 2001?
Your answer should be compact. 0.26. What is the ratio of the Value added (in %) of Japan in 1994 to that in 2001?
Offer a very short reply. 1.53. What is the ratio of the Value added (in %) in Malta in 1994 to that in 2001?
Your response must be concise. 1.53. What is the ratio of the Value added (in %) of Nepal in 1994 to that in 2001?
Keep it short and to the point. 2.27. What is the ratio of the Value added (in %) of Hungary in 1996 to that in 2001?
Give a very brief answer. 0.22. What is the ratio of the Value added (in %) of Japan in 1996 to that in 2001?
Make the answer very short. 1.34. What is the ratio of the Value added (in %) of Malta in 1996 to that in 2001?
Give a very brief answer. 1.25. What is the ratio of the Value added (in %) of Nepal in 1996 to that in 2001?
Provide a succinct answer. 1.74. What is the difference between the highest and the second highest Value added (in %) of Hungary?
Give a very brief answer. 0.16. What is the difference between the highest and the second highest Value added (in %) in Japan?
Give a very brief answer. 0.29. What is the difference between the highest and the second highest Value added (in %) of Malta?
Provide a short and direct response. 4.75. What is the difference between the highest and the second highest Value added (in %) in Nepal?
Offer a very short reply. 4.41. What is the difference between the highest and the lowest Value added (in %) in Hungary?
Provide a short and direct response. 8.8. What is the difference between the highest and the lowest Value added (in %) of Japan?
Provide a succinct answer. 2.54. What is the difference between the highest and the lowest Value added (in %) in Malta?
Ensure brevity in your answer.  15.52. What is the difference between the highest and the lowest Value added (in %) in Nepal?
Offer a very short reply. 24.53. 